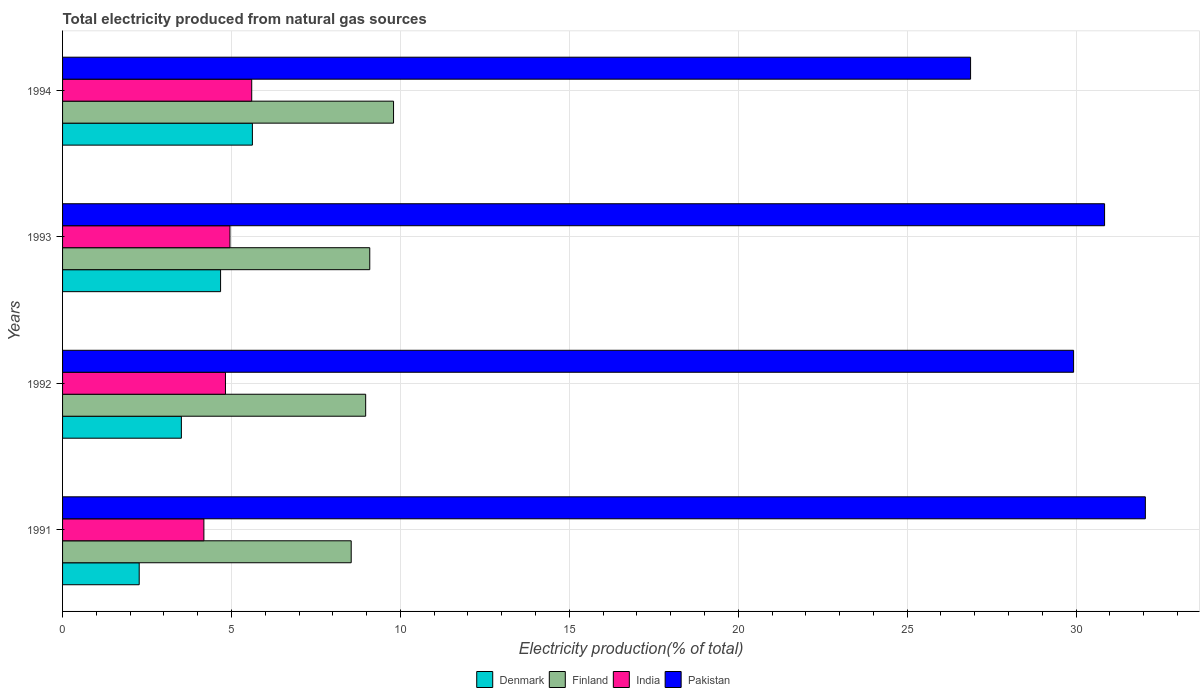Are the number of bars per tick equal to the number of legend labels?
Make the answer very short. Yes. Are the number of bars on each tick of the Y-axis equal?
Provide a short and direct response. Yes. How many bars are there on the 3rd tick from the top?
Ensure brevity in your answer.  4. What is the label of the 4th group of bars from the top?
Your answer should be very brief. 1991. In how many cases, is the number of bars for a given year not equal to the number of legend labels?
Offer a terse response. 0. What is the total electricity produced in Pakistan in 1992?
Make the answer very short. 29.93. Across all years, what is the maximum total electricity produced in Pakistan?
Ensure brevity in your answer.  32.05. Across all years, what is the minimum total electricity produced in India?
Your answer should be compact. 4.18. In which year was the total electricity produced in India minimum?
Your response must be concise. 1991. What is the total total electricity produced in Finland in the graph?
Your answer should be compact. 36.41. What is the difference between the total electricity produced in Finland in 1992 and that in 1993?
Your response must be concise. -0.12. What is the difference between the total electricity produced in Denmark in 1993 and the total electricity produced in Pakistan in 1991?
Make the answer very short. -27.37. What is the average total electricity produced in Finland per year?
Provide a succinct answer. 9.1. In the year 1993, what is the difference between the total electricity produced in Pakistan and total electricity produced in Denmark?
Ensure brevity in your answer.  26.17. In how many years, is the total electricity produced in Finland greater than 29 %?
Offer a terse response. 0. What is the ratio of the total electricity produced in Finland in 1991 to that in 1993?
Your answer should be very brief. 0.94. What is the difference between the highest and the second highest total electricity produced in Finland?
Your answer should be very brief. 0.7. What is the difference between the highest and the lowest total electricity produced in India?
Give a very brief answer. 1.42. In how many years, is the total electricity produced in Finland greater than the average total electricity produced in Finland taken over all years?
Your answer should be compact. 1. How many bars are there?
Provide a succinct answer. 16. Are the values on the major ticks of X-axis written in scientific E-notation?
Provide a succinct answer. No. Does the graph contain any zero values?
Offer a very short reply. No. Where does the legend appear in the graph?
Provide a short and direct response. Bottom center. How many legend labels are there?
Keep it short and to the point. 4. What is the title of the graph?
Make the answer very short. Total electricity produced from natural gas sources. What is the label or title of the X-axis?
Keep it short and to the point. Electricity production(% of total). What is the Electricity production(% of total) of Denmark in 1991?
Offer a very short reply. 2.27. What is the Electricity production(% of total) of Finland in 1991?
Keep it short and to the point. 8.54. What is the Electricity production(% of total) in India in 1991?
Your response must be concise. 4.18. What is the Electricity production(% of total) of Pakistan in 1991?
Give a very brief answer. 32.05. What is the Electricity production(% of total) of Denmark in 1992?
Ensure brevity in your answer.  3.52. What is the Electricity production(% of total) of Finland in 1992?
Provide a short and direct response. 8.97. What is the Electricity production(% of total) in India in 1992?
Give a very brief answer. 4.82. What is the Electricity production(% of total) of Pakistan in 1992?
Provide a succinct answer. 29.93. What is the Electricity production(% of total) in Denmark in 1993?
Your answer should be very brief. 4.68. What is the Electricity production(% of total) of Finland in 1993?
Offer a very short reply. 9.09. What is the Electricity production(% of total) of India in 1993?
Make the answer very short. 4.95. What is the Electricity production(% of total) in Pakistan in 1993?
Give a very brief answer. 30.84. What is the Electricity production(% of total) of Denmark in 1994?
Offer a terse response. 5.62. What is the Electricity production(% of total) of Finland in 1994?
Your answer should be compact. 9.8. What is the Electricity production(% of total) in India in 1994?
Keep it short and to the point. 5.6. What is the Electricity production(% of total) in Pakistan in 1994?
Provide a succinct answer. 26.88. Across all years, what is the maximum Electricity production(% of total) in Denmark?
Your response must be concise. 5.62. Across all years, what is the maximum Electricity production(% of total) of Finland?
Your answer should be compact. 9.8. Across all years, what is the maximum Electricity production(% of total) of India?
Ensure brevity in your answer.  5.6. Across all years, what is the maximum Electricity production(% of total) in Pakistan?
Provide a succinct answer. 32.05. Across all years, what is the minimum Electricity production(% of total) in Denmark?
Ensure brevity in your answer.  2.27. Across all years, what is the minimum Electricity production(% of total) in Finland?
Provide a short and direct response. 8.54. Across all years, what is the minimum Electricity production(% of total) of India?
Provide a succinct answer. 4.18. Across all years, what is the minimum Electricity production(% of total) of Pakistan?
Make the answer very short. 26.88. What is the total Electricity production(% of total) in Denmark in the graph?
Your answer should be very brief. 16.08. What is the total Electricity production(% of total) of Finland in the graph?
Make the answer very short. 36.41. What is the total Electricity production(% of total) of India in the graph?
Your response must be concise. 19.56. What is the total Electricity production(% of total) of Pakistan in the graph?
Offer a very short reply. 119.7. What is the difference between the Electricity production(% of total) of Denmark in 1991 and that in 1992?
Your answer should be compact. -1.25. What is the difference between the Electricity production(% of total) of Finland in 1991 and that in 1992?
Provide a short and direct response. -0.43. What is the difference between the Electricity production(% of total) of India in 1991 and that in 1992?
Provide a succinct answer. -0.64. What is the difference between the Electricity production(% of total) in Pakistan in 1991 and that in 1992?
Your answer should be compact. 2.12. What is the difference between the Electricity production(% of total) in Denmark in 1991 and that in 1993?
Make the answer very short. -2.41. What is the difference between the Electricity production(% of total) of Finland in 1991 and that in 1993?
Provide a succinct answer. -0.55. What is the difference between the Electricity production(% of total) in India in 1991 and that in 1993?
Your answer should be compact. -0.77. What is the difference between the Electricity production(% of total) in Pakistan in 1991 and that in 1993?
Your answer should be very brief. 1.21. What is the difference between the Electricity production(% of total) in Denmark in 1991 and that in 1994?
Offer a terse response. -3.35. What is the difference between the Electricity production(% of total) of Finland in 1991 and that in 1994?
Provide a short and direct response. -1.25. What is the difference between the Electricity production(% of total) of India in 1991 and that in 1994?
Offer a terse response. -1.42. What is the difference between the Electricity production(% of total) of Pakistan in 1991 and that in 1994?
Your answer should be very brief. 5.17. What is the difference between the Electricity production(% of total) in Denmark in 1992 and that in 1993?
Provide a succinct answer. -1.16. What is the difference between the Electricity production(% of total) in Finland in 1992 and that in 1993?
Provide a short and direct response. -0.12. What is the difference between the Electricity production(% of total) in India in 1992 and that in 1993?
Keep it short and to the point. -0.13. What is the difference between the Electricity production(% of total) in Pakistan in 1992 and that in 1993?
Provide a succinct answer. -0.92. What is the difference between the Electricity production(% of total) in Denmark in 1992 and that in 1994?
Provide a succinct answer. -2.1. What is the difference between the Electricity production(% of total) in Finland in 1992 and that in 1994?
Ensure brevity in your answer.  -0.83. What is the difference between the Electricity production(% of total) of India in 1992 and that in 1994?
Provide a short and direct response. -0.78. What is the difference between the Electricity production(% of total) in Pakistan in 1992 and that in 1994?
Give a very brief answer. 3.05. What is the difference between the Electricity production(% of total) of Denmark in 1993 and that in 1994?
Keep it short and to the point. -0.94. What is the difference between the Electricity production(% of total) in Finland in 1993 and that in 1994?
Your answer should be compact. -0.7. What is the difference between the Electricity production(% of total) in India in 1993 and that in 1994?
Provide a short and direct response. -0.64. What is the difference between the Electricity production(% of total) in Pakistan in 1993 and that in 1994?
Make the answer very short. 3.97. What is the difference between the Electricity production(% of total) of Denmark in 1991 and the Electricity production(% of total) of Finland in 1992?
Make the answer very short. -6.7. What is the difference between the Electricity production(% of total) of Denmark in 1991 and the Electricity production(% of total) of India in 1992?
Your response must be concise. -2.55. What is the difference between the Electricity production(% of total) in Denmark in 1991 and the Electricity production(% of total) in Pakistan in 1992?
Offer a very short reply. -27.66. What is the difference between the Electricity production(% of total) of Finland in 1991 and the Electricity production(% of total) of India in 1992?
Give a very brief answer. 3.72. What is the difference between the Electricity production(% of total) of Finland in 1991 and the Electricity production(% of total) of Pakistan in 1992?
Your answer should be compact. -21.38. What is the difference between the Electricity production(% of total) of India in 1991 and the Electricity production(% of total) of Pakistan in 1992?
Keep it short and to the point. -25.74. What is the difference between the Electricity production(% of total) in Denmark in 1991 and the Electricity production(% of total) in Finland in 1993?
Offer a very short reply. -6.82. What is the difference between the Electricity production(% of total) of Denmark in 1991 and the Electricity production(% of total) of India in 1993?
Your response must be concise. -2.69. What is the difference between the Electricity production(% of total) of Denmark in 1991 and the Electricity production(% of total) of Pakistan in 1993?
Provide a short and direct response. -28.58. What is the difference between the Electricity production(% of total) of Finland in 1991 and the Electricity production(% of total) of India in 1993?
Your answer should be very brief. 3.59. What is the difference between the Electricity production(% of total) of Finland in 1991 and the Electricity production(% of total) of Pakistan in 1993?
Provide a short and direct response. -22.3. What is the difference between the Electricity production(% of total) of India in 1991 and the Electricity production(% of total) of Pakistan in 1993?
Your answer should be very brief. -26.66. What is the difference between the Electricity production(% of total) of Denmark in 1991 and the Electricity production(% of total) of Finland in 1994?
Keep it short and to the point. -7.53. What is the difference between the Electricity production(% of total) in Denmark in 1991 and the Electricity production(% of total) in India in 1994?
Make the answer very short. -3.33. What is the difference between the Electricity production(% of total) in Denmark in 1991 and the Electricity production(% of total) in Pakistan in 1994?
Keep it short and to the point. -24.61. What is the difference between the Electricity production(% of total) of Finland in 1991 and the Electricity production(% of total) of India in 1994?
Give a very brief answer. 2.94. What is the difference between the Electricity production(% of total) in Finland in 1991 and the Electricity production(% of total) in Pakistan in 1994?
Your answer should be very brief. -18.33. What is the difference between the Electricity production(% of total) in India in 1991 and the Electricity production(% of total) in Pakistan in 1994?
Keep it short and to the point. -22.69. What is the difference between the Electricity production(% of total) in Denmark in 1992 and the Electricity production(% of total) in Finland in 1993?
Make the answer very short. -5.58. What is the difference between the Electricity production(% of total) in Denmark in 1992 and the Electricity production(% of total) in India in 1993?
Ensure brevity in your answer.  -1.44. What is the difference between the Electricity production(% of total) in Denmark in 1992 and the Electricity production(% of total) in Pakistan in 1993?
Give a very brief answer. -27.33. What is the difference between the Electricity production(% of total) of Finland in 1992 and the Electricity production(% of total) of India in 1993?
Your response must be concise. 4.02. What is the difference between the Electricity production(% of total) in Finland in 1992 and the Electricity production(% of total) in Pakistan in 1993?
Your answer should be compact. -21.87. What is the difference between the Electricity production(% of total) in India in 1992 and the Electricity production(% of total) in Pakistan in 1993?
Your answer should be very brief. -26.02. What is the difference between the Electricity production(% of total) in Denmark in 1992 and the Electricity production(% of total) in Finland in 1994?
Your answer should be very brief. -6.28. What is the difference between the Electricity production(% of total) in Denmark in 1992 and the Electricity production(% of total) in India in 1994?
Offer a terse response. -2.08. What is the difference between the Electricity production(% of total) of Denmark in 1992 and the Electricity production(% of total) of Pakistan in 1994?
Your answer should be very brief. -23.36. What is the difference between the Electricity production(% of total) of Finland in 1992 and the Electricity production(% of total) of India in 1994?
Offer a very short reply. 3.37. What is the difference between the Electricity production(% of total) in Finland in 1992 and the Electricity production(% of total) in Pakistan in 1994?
Provide a short and direct response. -17.91. What is the difference between the Electricity production(% of total) of India in 1992 and the Electricity production(% of total) of Pakistan in 1994?
Your answer should be very brief. -22.06. What is the difference between the Electricity production(% of total) in Denmark in 1993 and the Electricity production(% of total) in Finland in 1994?
Your response must be concise. -5.12. What is the difference between the Electricity production(% of total) in Denmark in 1993 and the Electricity production(% of total) in India in 1994?
Keep it short and to the point. -0.92. What is the difference between the Electricity production(% of total) of Denmark in 1993 and the Electricity production(% of total) of Pakistan in 1994?
Ensure brevity in your answer.  -22.2. What is the difference between the Electricity production(% of total) in Finland in 1993 and the Electricity production(% of total) in India in 1994?
Provide a succinct answer. 3.49. What is the difference between the Electricity production(% of total) in Finland in 1993 and the Electricity production(% of total) in Pakistan in 1994?
Provide a short and direct response. -17.78. What is the difference between the Electricity production(% of total) of India in 1993 and the Electricity production(% of total) of Pakistan in 1994?
Your answer should be very brief. -21.92. What is the average Electricity production(% of total) of Denmark per year?
Give a very brief answer. 4.02. What is the average Electricity production(% of total) in Finland per year?
Your answer should be very brief. 9.1. What is the average Electricity production(% of total) in India per year?
Ensure brevity in your answer.  4.89. What is the average Electricity production(% of total) in Pakistan per year?
Your answer should be compact. 29.92. In the year 1991, what is the difference between the Electricity production(% of total) of Denmark and Electricity production(% of total) of Finland?
Your answer should be compact. -6.28. In the year 1991, what is the difference between the Electricity production(% of total) of Denmark and Electricity production(% of total) of India?
Your response must be concise. -1.91. In the year 1991, what is the difference between the Electricity production(% of total) in Denmark and Electricity production(% of total) in Pakistan?
Your response must be concise. -29.78. In the year 1991, what is the difference between the Electricity production(% of total) in Finland and Electricity production(% of total) in India?
Provide a short and direct response. 4.36. In the year 1991, what is the difference between the Electricity production(% of total) in Finland and Electricity production(% of total) in Pakistan?
Provide a short and direct response. -23.51. In the year 1991, what is the difference between the Electricity production(% of total) in India and Electricity production(% of total) in Pakistan?
Provide a short and direct response. -27.87. In the year 1992, what is the difference between the Electricity production(% of total) of Denmark and Electricity production(% of total) of Finland?
Ensure brevity in your answer.  -5.46. In the year 1992, what is the difference between the Electricity production(% of total) of Denmark and Electricity production(% of total) of India?
Your response must be concise. -1.3. In the year 1992, what is the difference between the Electricity production(% of total) in Denmark and Electricity production(% of total) in Pakistan?
Provide a short and direct response. -26.41. In the year 1992, what is the difference between the Electricity production(% of total) of Finland and Electricity production(% of total) of India?
Your answer should be very brief. 4.15. In the year 1992, what is the difference between the Electricity production(% of total) of Finland and Electricity production(% of total) of Pakistan?
Your answer should be compact. -20.95. In the year 1992, what is the difference between the Electricity production(% of total) in India and Electricity production(% of total) in Pakistan?
Give a very brief answer. -25.1. In the year 1993, what is the difference between the Electricity production(% of total) in Denmark and Electricity production(% of total) in Finland?
Your response must be concise. -4.42. In the year 1993, what is the difference between the Electricity production(% of total) in Denmark and Electricity production(% of total) in India?
Offer a very short reply. -0.28. In the year 1993, what is the difference between the Electricity production(% of total) in Denmark and Electricity production(% of total) in Pakistan?
Your answer should be very brief. -26.17. In the year 1993, what is the difference between the Electricity production(% of total) in Finland and Electricity production(% of total) in India?
Provide a short and direct response. 4.14. In the year 1993, what is the difference between the Electricity production(% of total) of Finland and Electricity production(% of total) of Pakistan?
Give a very brief answer. -21.75. In the year 1993, what is the difference between the Electricity production(% of total) of India and Electricity production(% of total) of Pakistan?
Make the answer very short. -25.89. In the year 1994, what is the difference between the Electricity production(% of total) of Denmark and Electricity production(% of total) of Finland?
Offer a very short reply. -4.18. In the year 1994, what is the difference between the Electricity production(% of total) in Denmark and Electricity production(% of total) in India?
Ensure brevity in your answer.  0.02. In the year 1994, what is the difference between the Electricity production(% of total) in Denmark and Electricity production(% of total) in Pakistan?
Provide a succinct answer. -21.26. In the year 1994, what is the difference between the Electricity production(% of total) in Finland and Electricity production(% of total) in India?
Make the answer very short. 4.2. In the year 1994, what is the difference between the Electricity production(% of total) of Finland and Electricity production(% of total) of Pakistan?
Provide a short and direct response. -17.08. In the year 1994, what is the difference between the Electricity production(% of total) of India and Electricity production(% of total) of Pakistan?
Keep it short and to the point. -21.28. What is the ratio of the Electricity production(% of total) in Denmark in 1991 to that in 1992?
Your answer should be compact. 0.65. What is the ratio of the Electricity production(% of total) of Finland in 1991 to that in 1992?
Your answer should be very brief. 0.95. What is the ratio of the Electricity production(% of total) of India in 1991 to that in 1992?
Keep it short and to the point. 0.87. What is the ratio of the Electricity production(% of total) of Pakistan in 1991 to that in 1992?
Keep it short and to the point. 1.07. What is the ratio of the Electricity production(% of total) of Denmark in 1991 to that in 1993?
Offer a very short reply. 0.48. What is the ratio of the Electricity production(% of total) in Finland in 1991 to that in 1993?
Make the answer very short. 0.94. What is the ratio of the Electricity production(% of total) in India in 1991 to that in 1993?
Provide a short and direct response. 0.84. What is the ratio of the Electricity production(% of total) of Pakistan in 1991 to that in 1993?
Your answer should be very brief. 1.04. What is the ratio of the Electricity production(% of total) in Denmark in 1991 to that in 1994?
Offer a terse response. 0.4. What is the ratio of the Electricity production(% of total) of Finland in 1991 to that in 1994?
Offer a terse response. 0.87. What is the ratio of the Electricity production(% of total) of India in 1991 to that in 1994?
Offer a very short reply. 0.75. What is the ratio of the Electricity production(% of total) in Pakistan in 1991 to that in 1994?
Your response must be concise. 1.19. What is the ratio of the Electricity production(% of total) of Denmark in 1992 to that in 1993?
Offer a terse response. 0.75. What is the ratio of the Electricity production(% of total) in Finland in 1992 to that in 1993?
Give a very brief answer. 0.99. What is the ratio of the Electricity production(% of total) of India in 1992 to that in 1993?
Provide a succinct answer. 0.97. What is the ratio of the Electricity production(% of total) of Pakistan in 1992 to that in 1993?
Keep it short and to the point. 0.97. What is the ratio of the Electricity production(% of total) in Denmark in 1992 to that in 1994?
Your response must be concise. 0.63. What is the ratio of the Electricity production(% of total) in Finland in 1992 to that in 1994?
Your response must be concise. 0.92. What is the ratio of the Electricity production(% of total) in India in 1992 to that in 1994?
Provide a short and direct response. 0.86. What is the ratio of the Electricity production(% of total) of Pakistan in 1992 to that in 1994?
Keep it short and to the point. 1.11. What is the ratio of the Electricity production(% of total) in Denmark in 1993 to that in 1994?
Provide a succinct answer. 0.83. What is the ratio of the Electricity production(% of total) in Finland in 1993 to that in 1994?
Your answer should be very brief. 0.93. What is the ratio of the Electricity production(% of total) of India in 1993 to that in 1994?
Provide a succinct answer. 0.88. What is the ratio of the Electricity production(% of total) of Pakistan in 1993 to that in 1994?
Provide a short and direct response. 1.15. What is the difference between the highest and the second highest Electricity production(% of total) of Denmark?
Offer a terse response. 0.94. What is the difference between the highest and the second highest Electricity production(% of total) in Finland?
Your response must be concise. 0.7. What is the difference between the highest and the second highest Electricity production(% of total) of India?
Offer a terse response. 0.64. What is the difference between the highest and the second highest Electricity production(% of total) of Pakistan?
Make the answer very short. 1.21. What is the difference between the highest and the lowest Electricity production(% of total) in Denmark?
Your answer should be compact. 3.35. What is the difference between the highest and the lowest Electricity production(% of total) of Finland?
Make the answer very short. 1.25. What is the difference between the highest and the lowest Electricity production(% of total) in India?
Ensure brevity in your answer.  1.42. What is the difference between the highest and the lowest Electricity production(% of total) of Pakistan?
Make the answer very short. 5.17. 